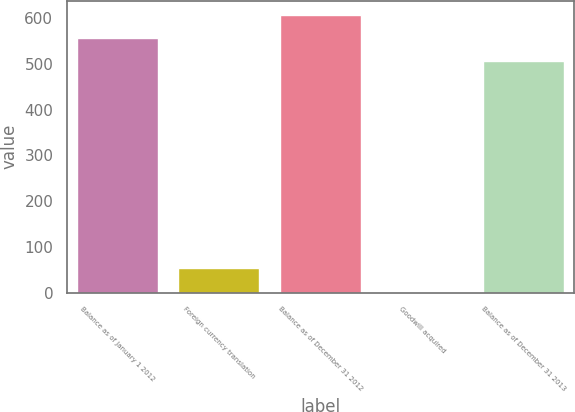Convert chart to OTSL. <chart><loc_0><loc_0><loc_500><loc_500><bar_chart><fcel>Balance as of January 1 2012<fcel>Foreign currency translation<fcel>Balance as of December 31 2012<fcel>Goodwill acquired<fcel>Balance as of December 31 2013<nl><fcel>557.1<fcel>53.1<fcel>608.2<fcel>2<fcel>506<nl></chart> 